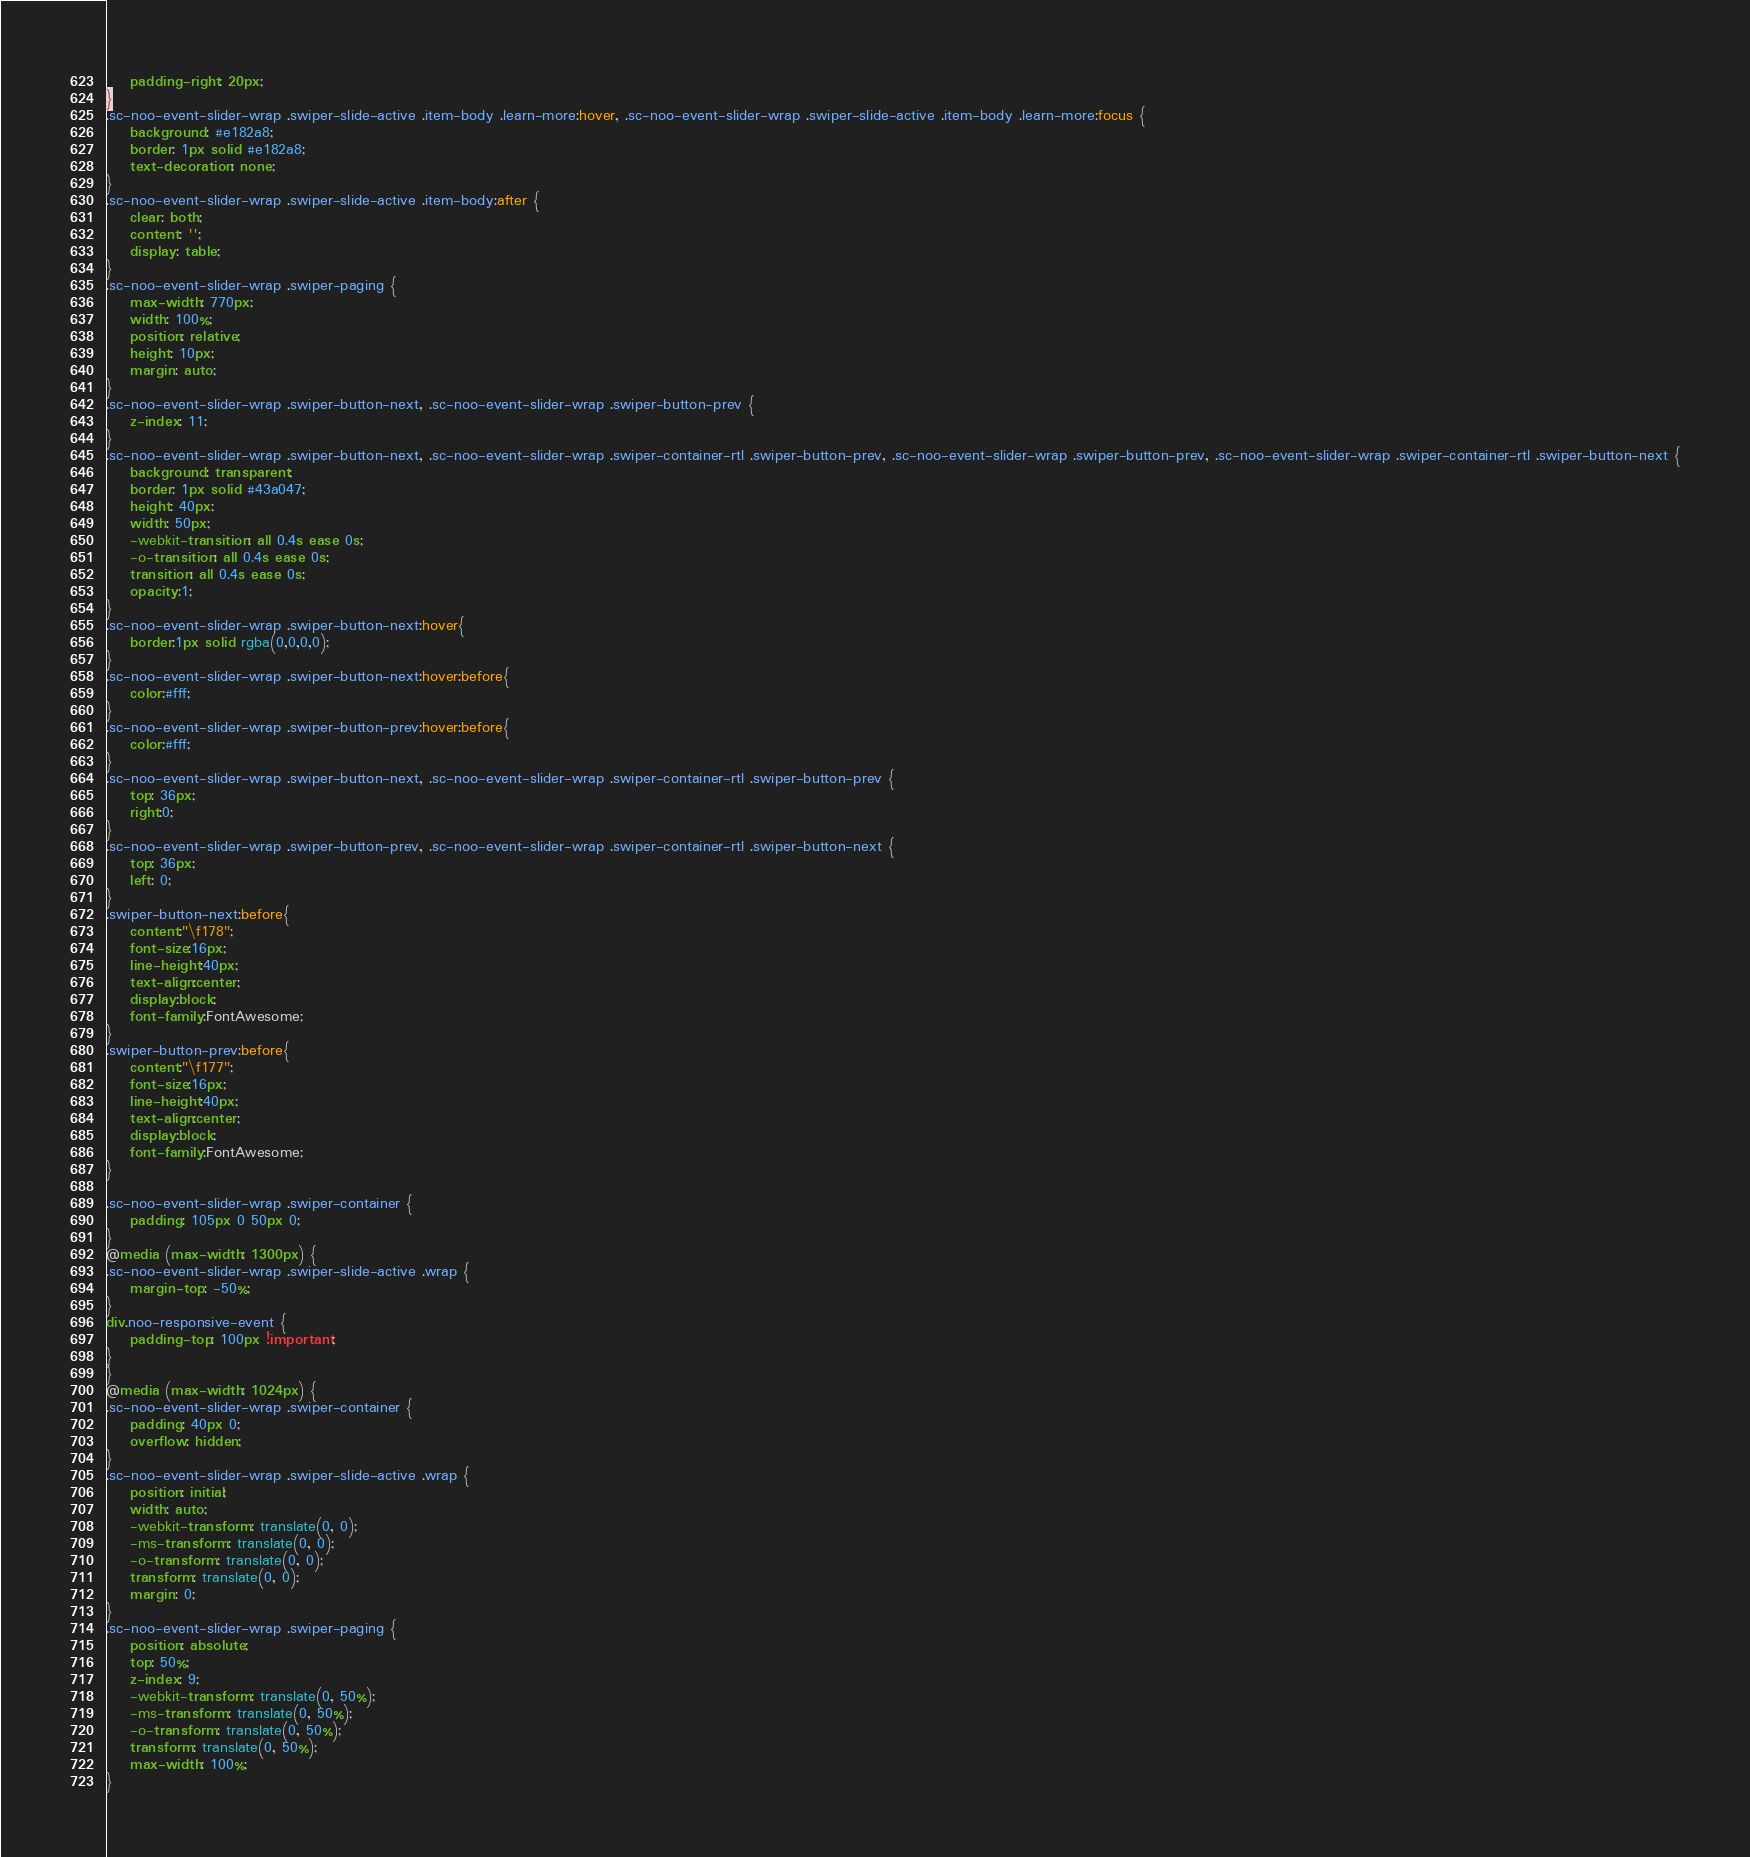<code> <loc_0><loc_0><loc_500><loc_500><_CSS_>	padding-right: 20px;
}
.sc-noo-event-slider-wrap .swiper-slide-active .item-body .learn-more:hover, .sc-noo-event-slider-wrap .swiper-slide-active .item-body .learn-more:focus {
	background: #e182a8;
	border: 1px solid #e182a8;
	text-decoration: none;
}
.sc-noo-event-slider-wrap .swiper-slide-active .item-body:after {
	clear: both;
	content: '';
	display: table;
}
.sc-noo-event-slider-wrap .swiper-paging {
	max-width: 770px;
	width: 100%;
	position: relative;
	height: 10px;
	margin: auto;
}
.sc-noo-event-slider-wrap .swiper-button-next, .sc-noo-event-slider-wrap .swiper-button-prev {
	z-index: 11;
}
.sc-noo-event-slider-wrap .swiper-button-next, .sc-noo-event-slider-wrap .swiper-container-rtl .swiper-button-prev, .sc-noo-event-slider-wrap .swiper-button-prev, .sc-noo-event-slider-wrap .swiper-container-rtl .swiper-button-next {
	background: transparent;
	border: 1px solid #43a047;
	height: 40px;
	width: 50px;
	-webkit-transition: all 0.4s ease 0s;
	-o-transition: all 0.4s ease 0s;
	transition: all 0.4s ease 0s;
	opacity:1;
}
.sc-noo-event-slider-wrap .swiper-button-next:hover{
	border:1px solid rgba(0,0,0,0);
}
.sc-noo-event-slider-wrap .swiper-button-next:hover:before{
	color:#fff;
}
.sc-noo-event-slider-wrap .swiper-button-prev:hover:before{
	color:#fff;
}
.sc-noo-event-slider-wrap .swiper-button-next, .sc-noo-event-slider-wrap .swiper-container-rtl .swiper-button-prev {
	top: 36px;
	right:0;
}
.sc-noo-event-slider-wrap .swiper-button-prev, .sc-noo-event-slider-wrap .swiper-container-rtl .swiper-button-next {
	top: 36px;
	left: 0;
}
.swiper-button-next:before{
	content:"\f178";
	font-size:16px;
	line-height:40px;
	text-align:center;
	display:block;
	font-family:FontAwesome;
}
.swiper-button-prev:before{
	content:"\f177";
	font-size:16px;
	line-height:40px;
	text-align:center;
	display:block;
	font-family:FontAwesome;
}

.sc-noo-event-slider-wrap .swiper-container {
	padding: 105px 0 50px 0;
}
@media (max-width: 1300px) {
.sc-noo-event-slider-wrap .swiper-slide-active .wrap {
	margin-top: -50%;
}
div.noo-responsive-event {
	padding-top: 100px !important;
}
}
@media (max-width: 1024px) {
.sc-noo-event-slider-wrap .swiper-container {
	padding: 40px 0;
	overflow: hidden;
}
.sc-noo-event-slider-wrap .swiper-slide-active .wrap {
	position: initial;
	width: auto;
	-webkit-transform: translate(0, 0);
	-ms-transform: translate(0, 0);
	-o-transform: translate(0, 0);
	transform: translate(0, 0);
	margin: 0;
}
.sc-noo-event-slider-wrap .swiper-paging {
	position: absolute;
	top: 50%;
	z-index: 9;
	-webkit-transform: translate(0, 50%);
	-ms-transform: translate(0, 50%);
	-o-transform: translate(0, 50%);
	transform: translate(0, 50%);
	max-width: 100%;
}</code> 